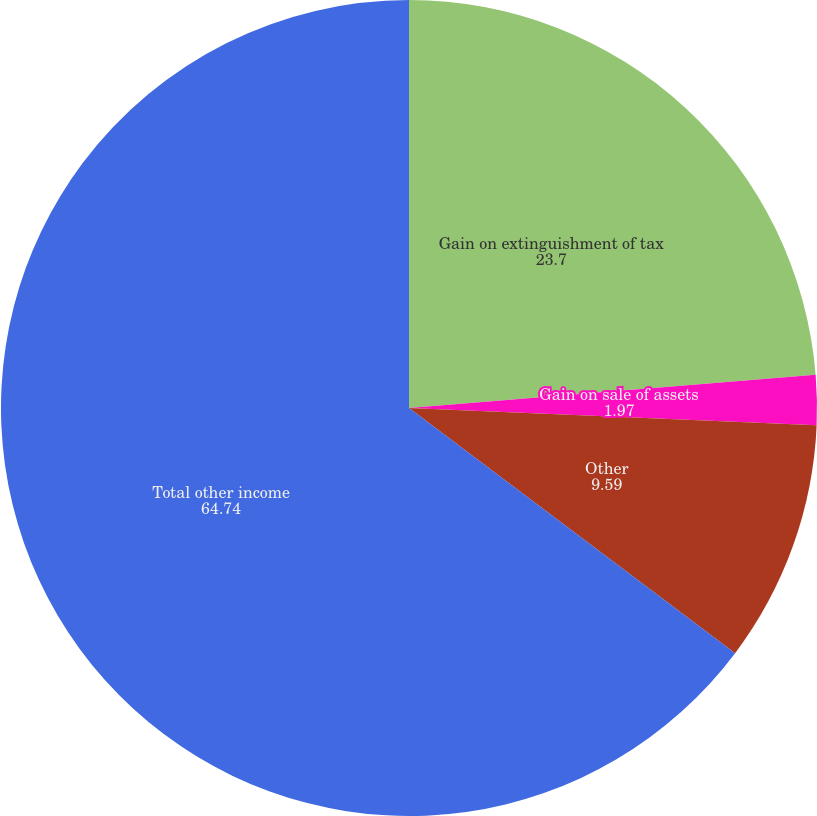<chart> <loc_0><loc_0><loc_500><loc_500><pie_chart><fcel>Gain on extinguishment of tax<fcel>Gain on sale of assets<fcel>Other<fcel>Total other income<nl><fcel>23.7%<fcel>1.97%<fcel>9.59%<fcel>64.74%<nl></chart> 